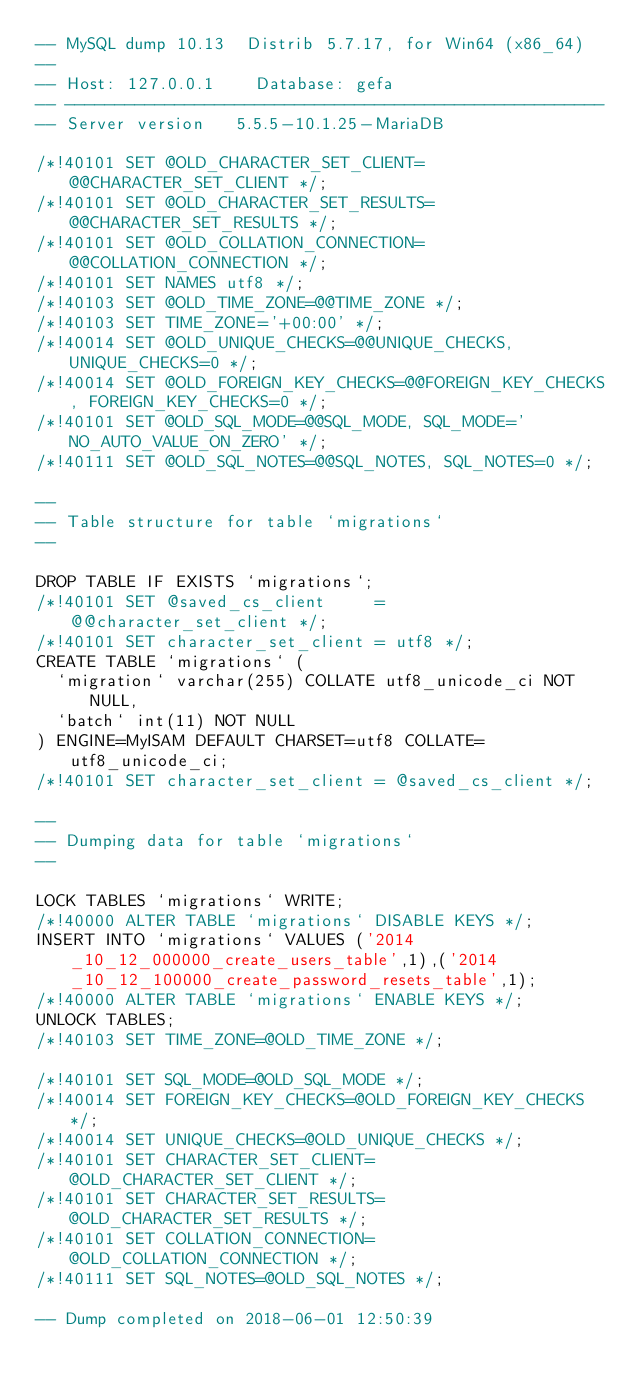Convert code to text. <code><loc_0><loc_0><loc_500><loc_500><_SQL_>-- MySQL dump 10.13  Distrib 5.7.17, for Win64 (x86_64)
--
-- Host: 127.0.0.1    Database: gefa
-- ------------------------------------------------------
-- Server version	5.5.5-10.1.25-MariaDB

/*!40101 SET @OLD_CHARACTER_SET_CLIENT=@@CHARACTER_SET_CLIENT */;
/*!40101 SET @OLD_CHARACTER_SET_RESULTS=@@CHARACTER_SET_RESULTS */;
/*!40101 SET @OLD_COLLATION_CONNECTION=@@COLLATION_CONNECTION */;
/*!40101 SET NAMES utf8 */;
/*!40103 SET @OLD_TIME_ZONE=@@TIME_ZONE */;
/*!40103 SET TIME_ZONE='+00:00' */;
/*!40014 SET @OLD_UNIQUE_CHECKS=@@UNIQUE_CHECKS, UNIQUE_CHECKS=0 */;
/*!40014 SET @OLD_FOREIGN_KEY_CHECKS=@@FOREIGN_KEY_CHECKS, FOREIGN_KEY_CHECKS=0 */;
/*!40101 SET @OLD_SQL_MODE=@@SQL_MODE, SQL_MODE='NO_AUTO_VALUE_ON_ZERO' */;
/*!40111 SET @OLD_SQL_NOTES=@@SQL_NOTES, SQL_NOTES=0 */;

--
-- Table structure for table `migrations`
--

DROP TABLE IF EXISTS `migrations`;
/*!40101 SET @saved_cs_client     = @@character_set_client */;
/*!40101 SET character_set_client = utf8 */;
CREATE TABLE `migrations` (
  `migration` varchar(255) COLLATE utf8_unicode_ci NOT NULL,
  `batch` int(11) NOT NULL
) ENGINE=MyISAM DEFAULT CHARSET=utf8 COLLATE=utf8_unicode_ci;
/*!40101 SET character_set_client = @saved_cs_client */;

--
-- Dumping data for table `migrations`
--

LOCK TABLES `migrations` WRITE;
/*!40000 ALTER TABLE `migrations` DISABLE KEYS */;
INSERT INTO `migrations` VALUES ('2014_10_12_000000_create_users_table',1),('2014_10_12_100000_create_password_resets_table',1);
/*!40000 ALTER TABLE `migrations` ENABLE KEYS */;
UNLOCK TABLES;
/*!40103 SET TIME_ZONE=@OLD_TIME_ZONE */;

/*!40101 SET SQL_MODE=@OLD_SQL_MODE */;
/*!40014 SET FOREIGN_KEY_CHECKS=@OLD_FOREIGN_KEY_CHECKS */;
/*!40014 SET UNIQUE_CHECKS=@OLD_UNIQUE_CHECKS */;
/*!40101 SET CHARACTER_SET_CLIENT=@OLD_CHARACTER_SET_CLIENT */;
/*!40101 SET CHARACTER_SET_RESULTS=@OLD_CHARACTER_SET_RESULTS */;
/*!40101 SET COLLATION_CONNECTION=@OLD_COLLATION_CONNECTION */;
/*!40111 SET SQL_NOTES=@OLD_SQL_NOTES */;

-- Dump completed on 2018-06-01 12:50:39
</code> 